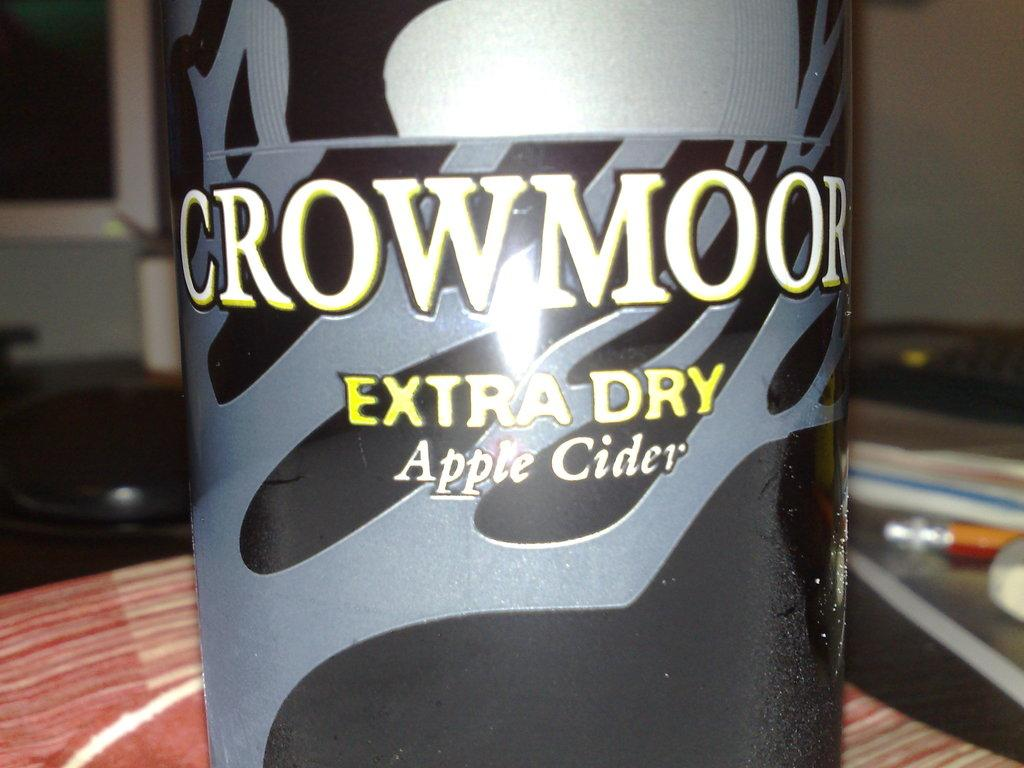<image>
Create a compact narrative representing the image presented. A black and grey bottle contains Crowmoor apple cider. 